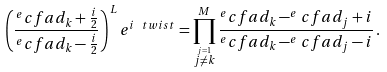<formula> <loc_0><loc_0><loc_500><loc_500>\left ( \frac { ^ { e } c f a d _ { k } + \frac { i } { 2 } } { ^ { e } c f a d _ { k } - \frac { i } { 2 } } \right ) ^ { L } e ^ { i \ t w i s t } = \prod _ { \stackrel { j = 1 } { j \neq k } } ^ { M } \frac { ^ { e } c f a d _ { k } - ^ { e } c f a d _ { j } + i } { ^ { e } c f a d _ { k } - ^ { e } c f a d _ { j } - i } \, .</formula> 